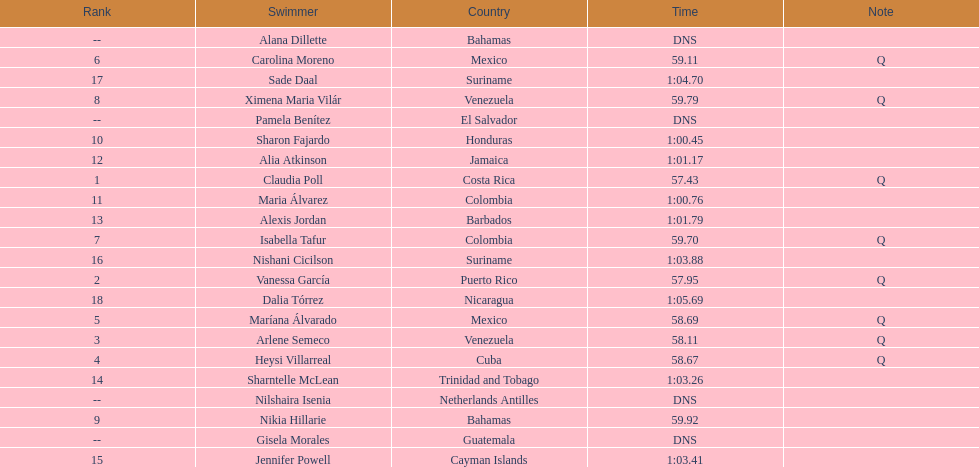How many competitors did not start the preliminaries? 4. 